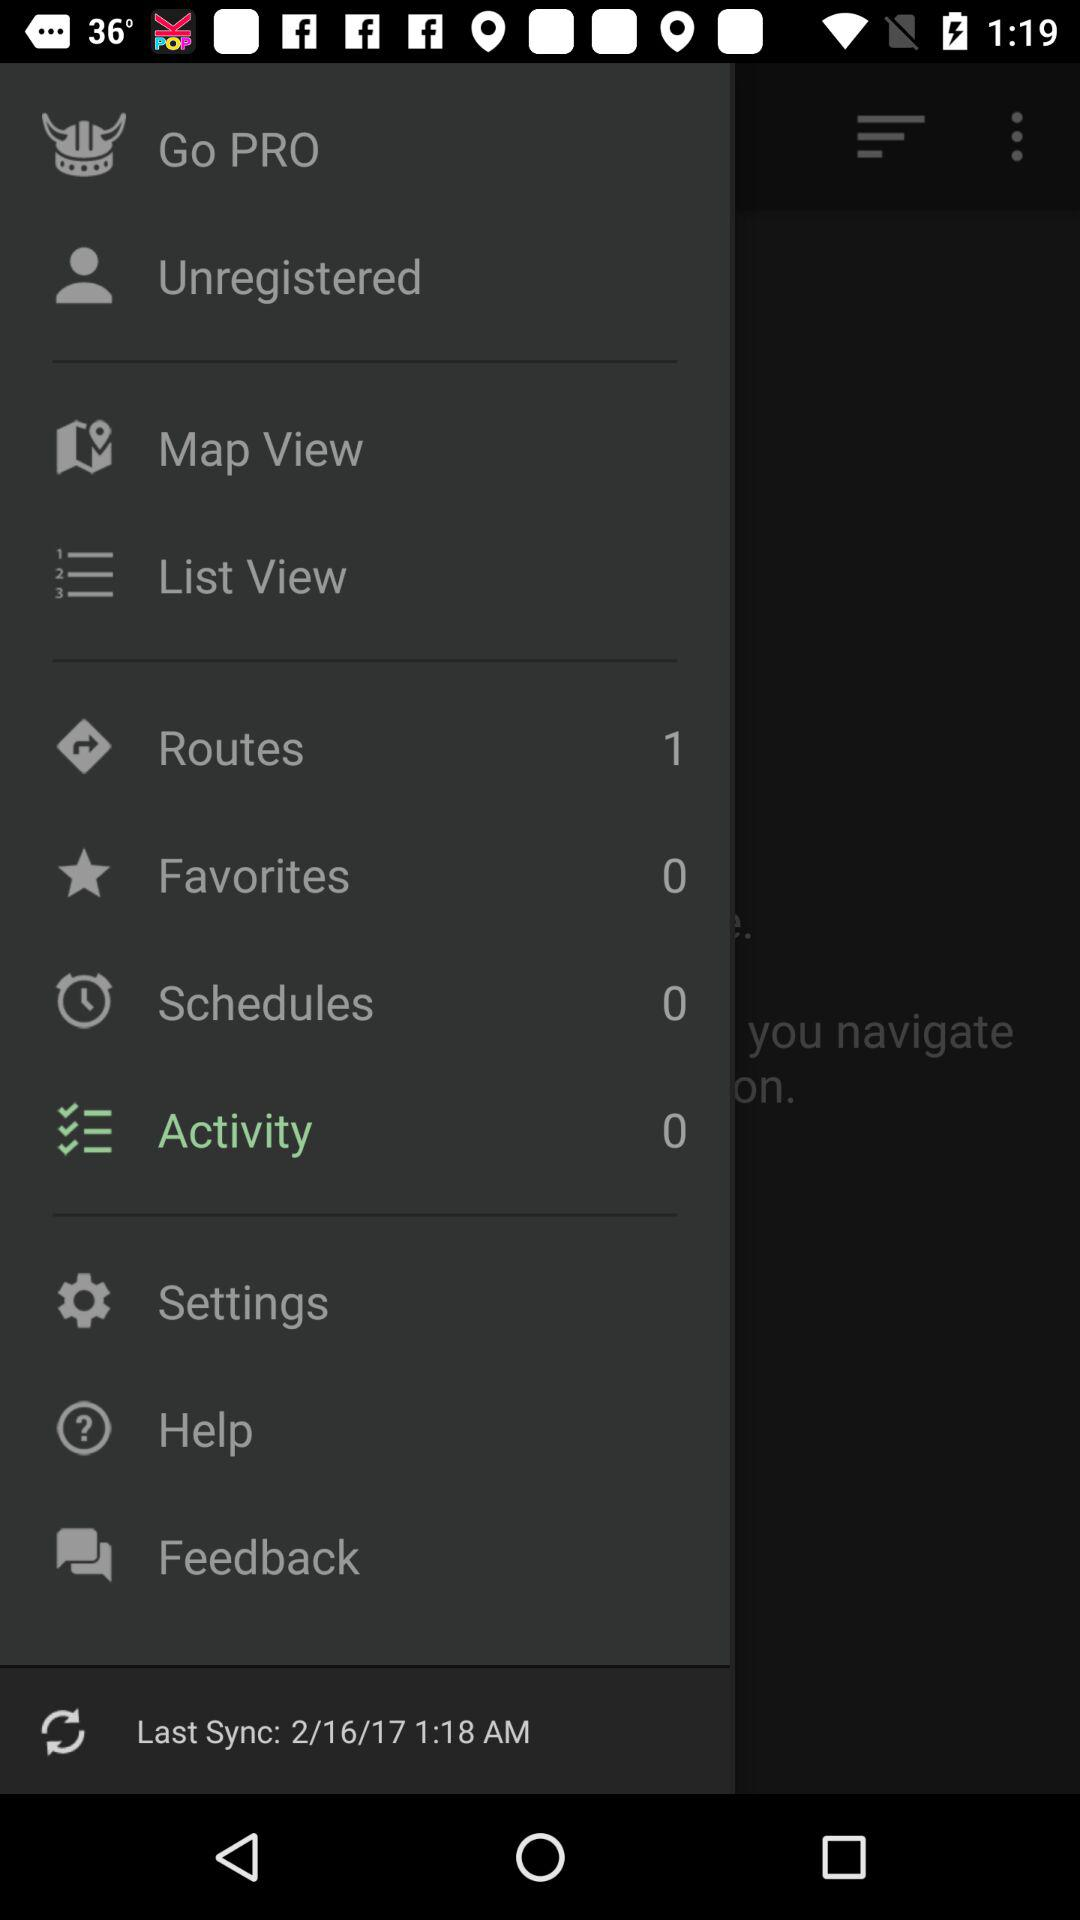How many items are there in "Activity"? There are 0 items in "Activity". 